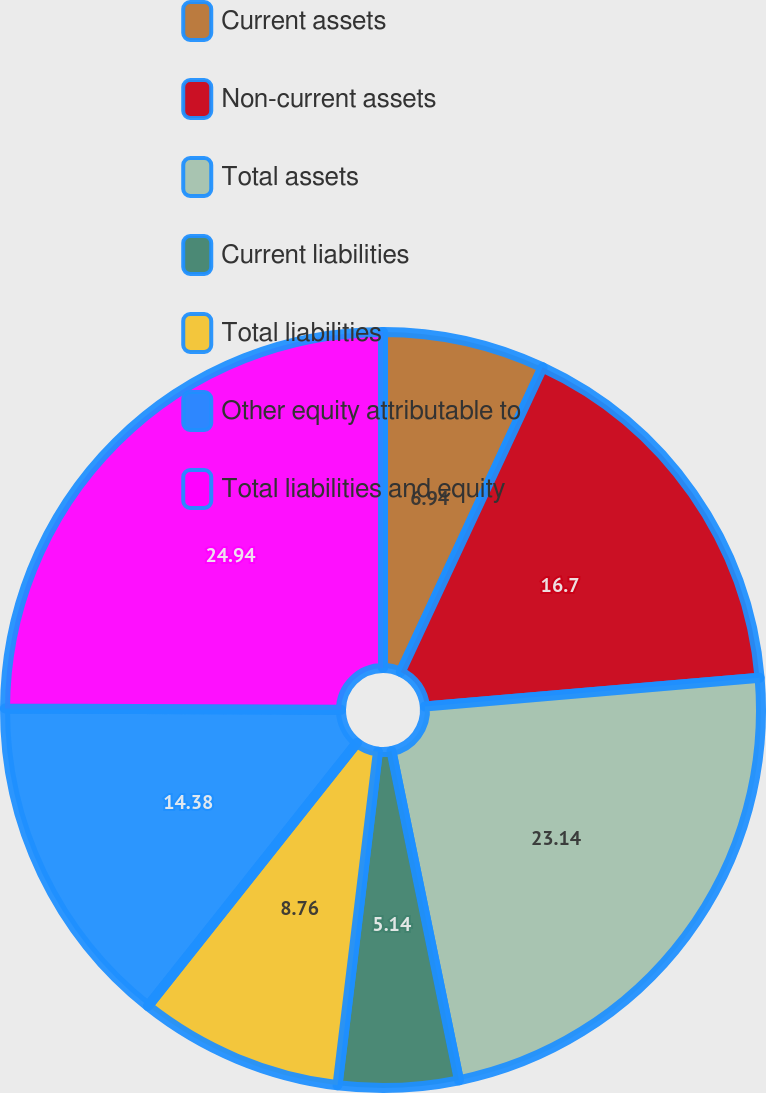<chart> <loc_0><loc_0><loc_500><loc_500><pie_chart><fcel>Current assets<fcel>Non-current assets<fcel>Total assets<fcel>Current liabilities<fcel>Total liabilities<fcel>Other equity attributable to<fcel>Total liabilities and equity<nl><fcel>6.94%<fcel>16.7%<fcel>23.14%<fcel>5.14%<fcel>8.76%<fcel>14.38%<fcel>24.94%<nl></chart> 